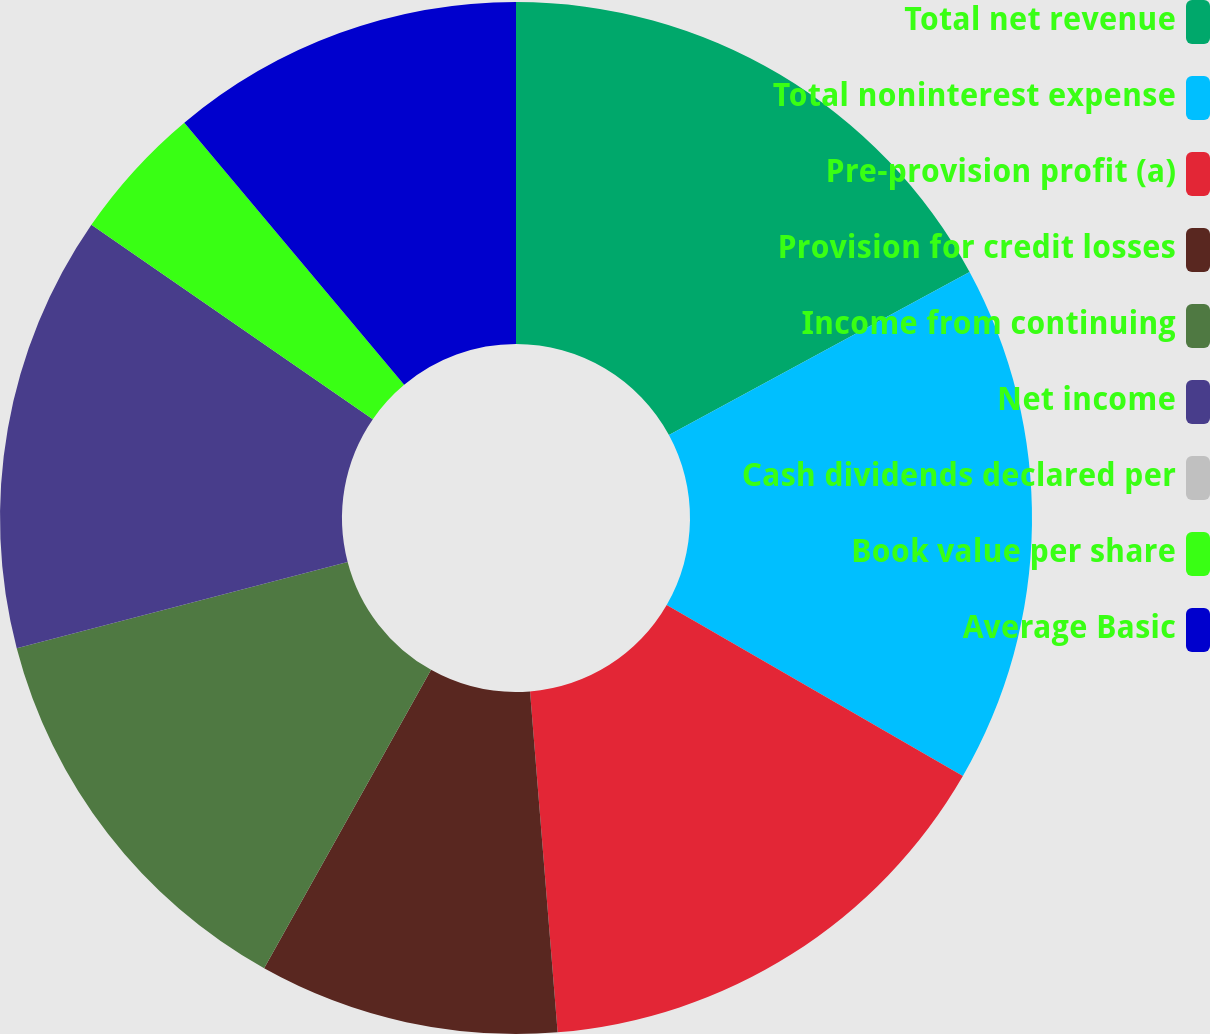Convert chart. <chart><loc_0><loc_0><loc_500><loc_500><pie_chart><fcel>Total net revenue<fcel>Total noninterest expense<fcel>Pre-provision profit (a)<fcel>Provision for credit losses<fcel>Income from continuing<fcel>Net income<fcel>Cash dividends declared per<fcel>Book value per share<fcel>Average Basic<nl><fcel>17.09%<fcel>16.24%<fcel>15.38%<fcel>9.4%<fcel>12.82%<fcel>13.68%<fcel>0.0%<fcel>4.27%<fcel>11.11%<nl></chart> 